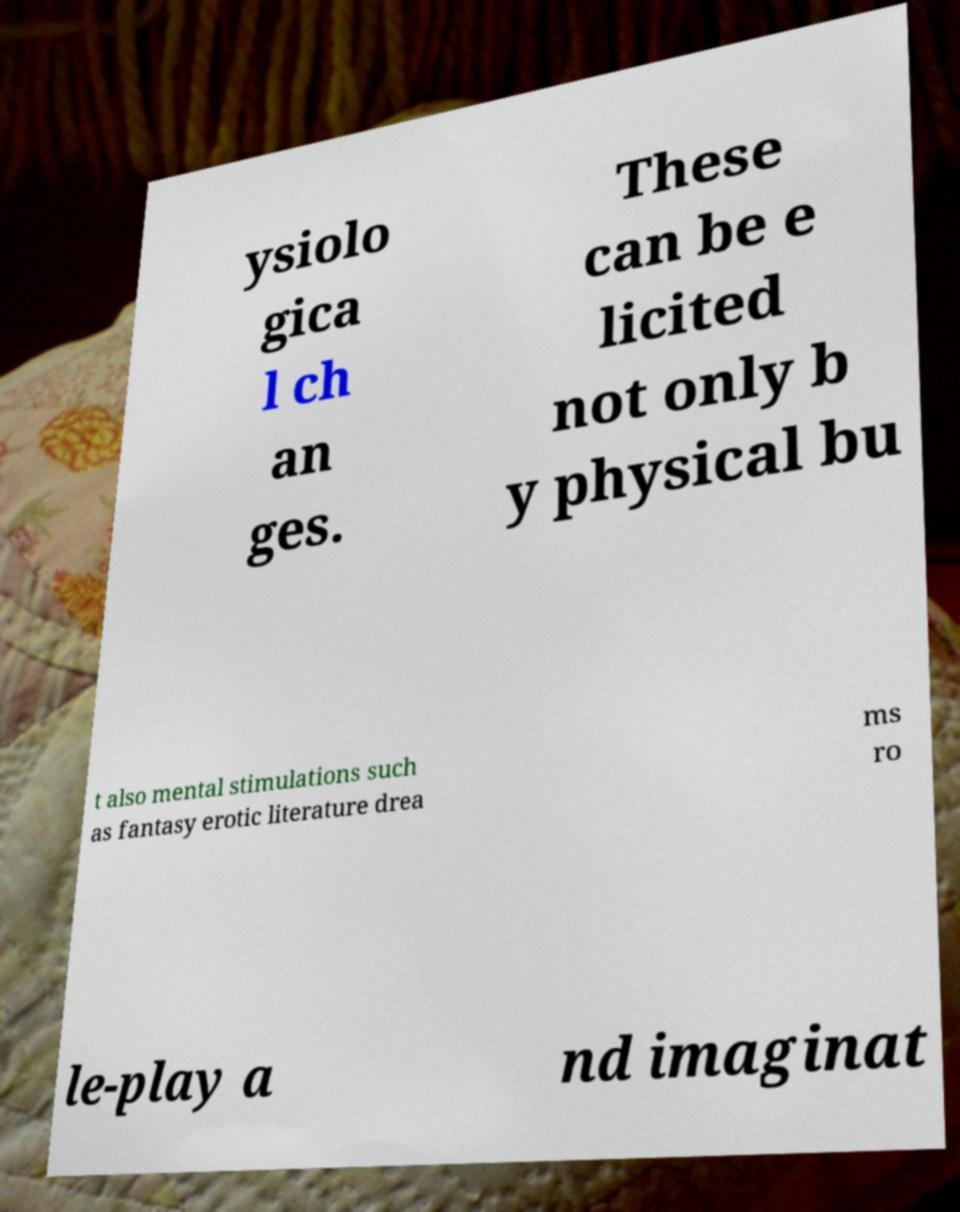Can you read and provide the text displayed in the image?This photo seems to have some interesting text. Can you extract and type it out for me? ysiolo gica l ch an ges. These can be e licited not only b y physical bu t also mental stimulations such as fantasy erotic literature drea ms ro le-play a nd imaginat 